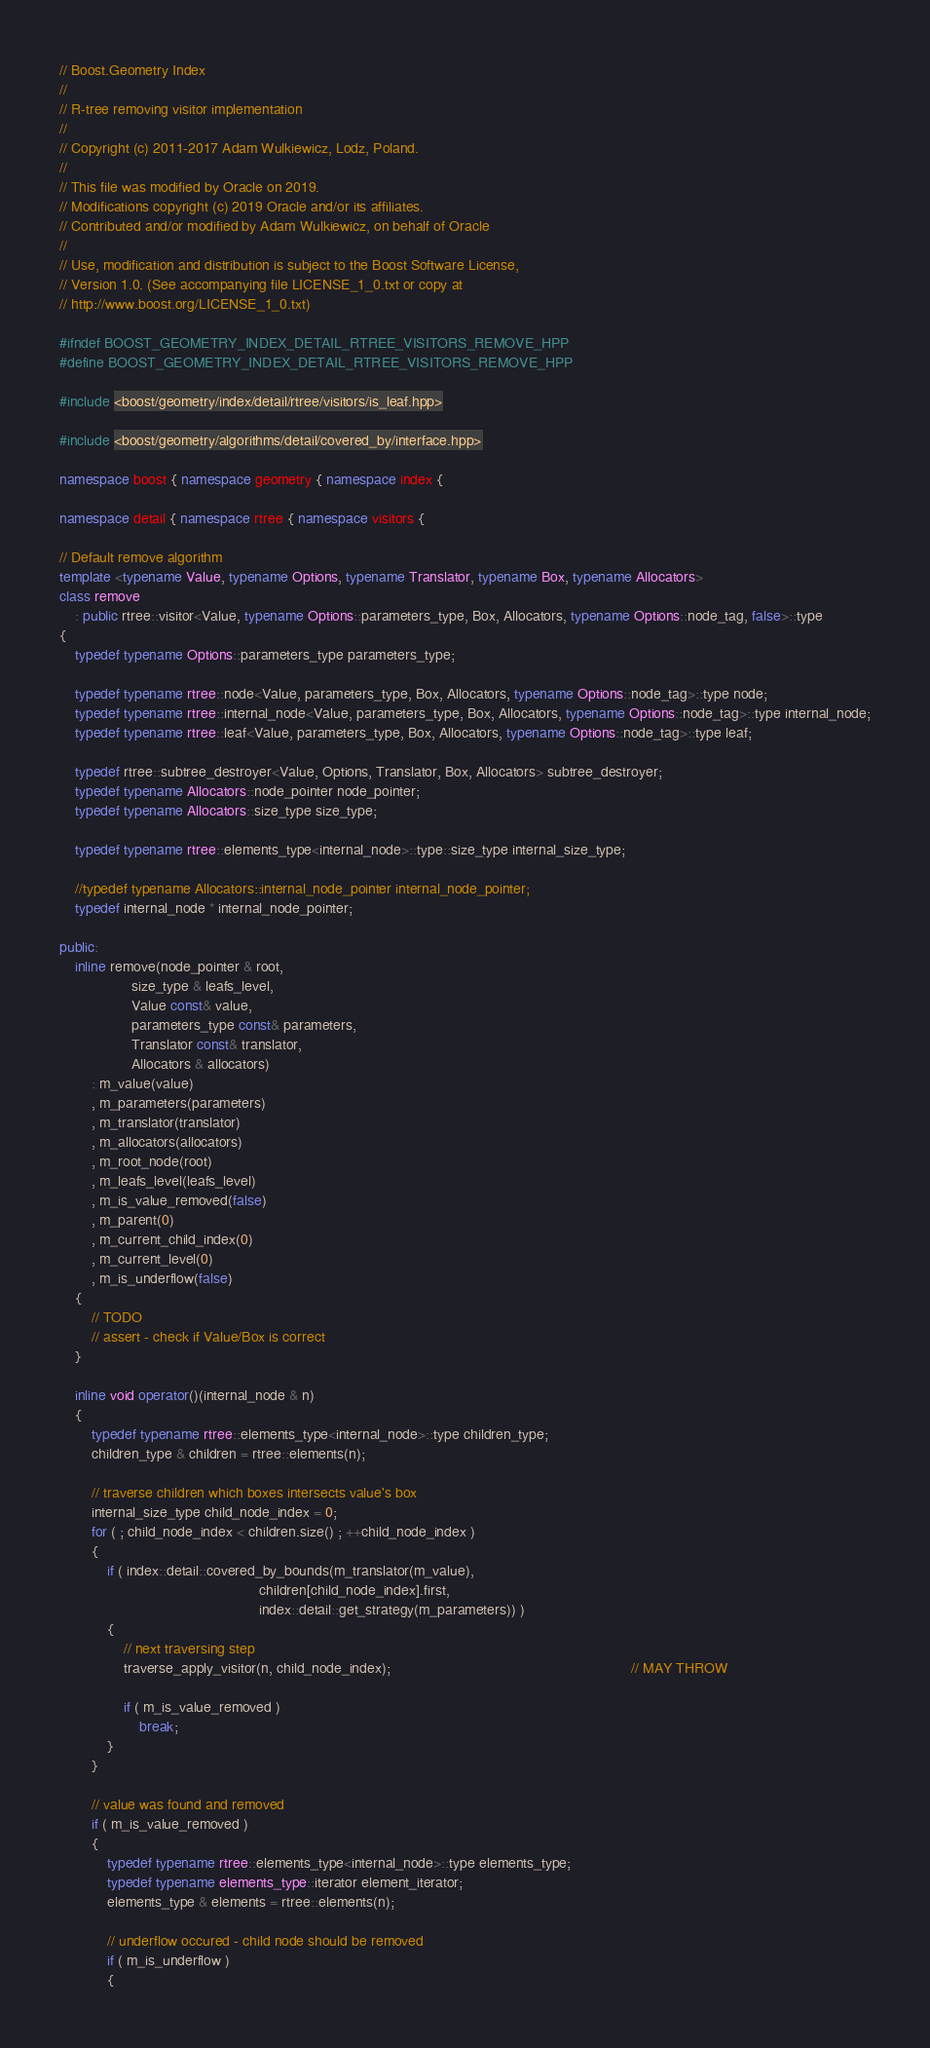<code> <loc_0><loc_0><loc_500><loc_500><_C++_>// Boost.Geometry Index
//
// R-tree removing visitor implementation
//
// Copyright (c) 2011-2017 Adam Wulkiewicz, Lodz, Poland.
//
// This file was modified by Oracle on 2019.
// Modifications copyright (c) 2019 Oracle and/or its affiliates.
// Contributed and/or modified by Adam Wulkiewicz, on behalf of Oracle
//
// Use, modification and distribution is subject to the Boost Software License,
// Version 1.0. (See accompanying file LICENSE_1_0.txt or copy at
// http://www.boost.org/LICENSE_1_0.txt)

#ifndef BOOST_GEOMETRY_INDEX_DETAIL_RTREE_VISITORS_REMOVE_HPP
#define BOOST_GEOMETRY_INDEX_DETAIL_RTREE_VISITORS_REMOVE_HPP

#include <boost/geometry/index/detail/rtree/visitors/is_leaf.hpp>

#include <boost/geometry/algorithms/detail/covered_by/interface.hpp>

namespace boost { namespace geometry { namespace index {

namespace detail { namespace rtree { namespace visitors {

// Default remove algorithm
template <typename Value, typename Options, typename Translator, typename Box, typename Allocators>
class remove
    : public rtree::visitor<Value, typename Options::parameters_type, Box, Allocators, typename Options::node_tag, false>::type
{
    typedef typename Options::parameters_type parameters_type;

    typedef typename rtree::node<Value, parameters_type, Box, Allocators, typename Options::node_tag>::type node;
    typedef typename rtree::internal_node<Value, parameters_type, Box, Allocators, typename Options::node_tag>::type internal_node;
    typedef typename rtree::leaf<Value, parameters_type, Box, Allocators, typename Options::node_tag>::type leaf;

    typedef rtree::subtree_destroyer<Value, Options, Translator, Box, Allocators> subtree_destroyer;
    typedef typename Allocators::node_pointer node_pointer;
    typedef typename Allocators::size_type size_type;

    typedef typename rtree::elements_type<internal_node>::type::size_type internal_size_type;

    //typedef typename Allocators::internal_node_pointer internal_node_pointer;
    typedef internal_node * internal_node_pointer;

public:
    inline remove(node_pointer & root,
                  size_type & leafs_level,
                  Value const& value,
                  parameters_type const& parameters,
                  Translator const& translator,
                  Allocators & allocators)
        : m_value(value)
        , m_parameters(parameters)
        , m_translator(translator)
        , m_allocators(allocators)
        , m_root_node(root)
        , m_leafs_level(leafs_level)
        , m_is_value_removed(false)
        , m_parent(0)
        , m_current_child_index(0)
        , m_current_level(0)
        , m_is_underflow(false)
    {
        // TODO
        // assert - check if Value/Box is correct
    }

    inline void operator()(internal_node & n)
    {
        typedef typename rtree::elements_type<internal_node>::type children_type;
        children_type & children = rtree::elements(n);

        // traverse children which boxes intersects value's box
        internal_size_type child_node_index = 0;
        for ( ; child_node_index < children.size() ; ++child_node_index )
        {
            if ( index::detail::covered_by_bounds(m_translator(m_value),
                                                  children[child_node_index].first,
                                                  index::detail::get_strategy(m_parameters)) )
            {
                // next traversing step
                traverse_apply_visitor(n, child_node_index);                                                            // MAY THROW

                if ( m_is_value_removed )
                    break;
            }
        }

        // value was found and removed
        if ( m_is_value_removed )
        {
            typedef typename rtree::elements_type<internal_node>::type elements_type;
            typedef typename elements_type::iterator element_iterator;
            elements_type & elements = rtree::elements(n);

            // underflow occured - child node should be removed
            if ( m_is_underflow )
            {</code> 